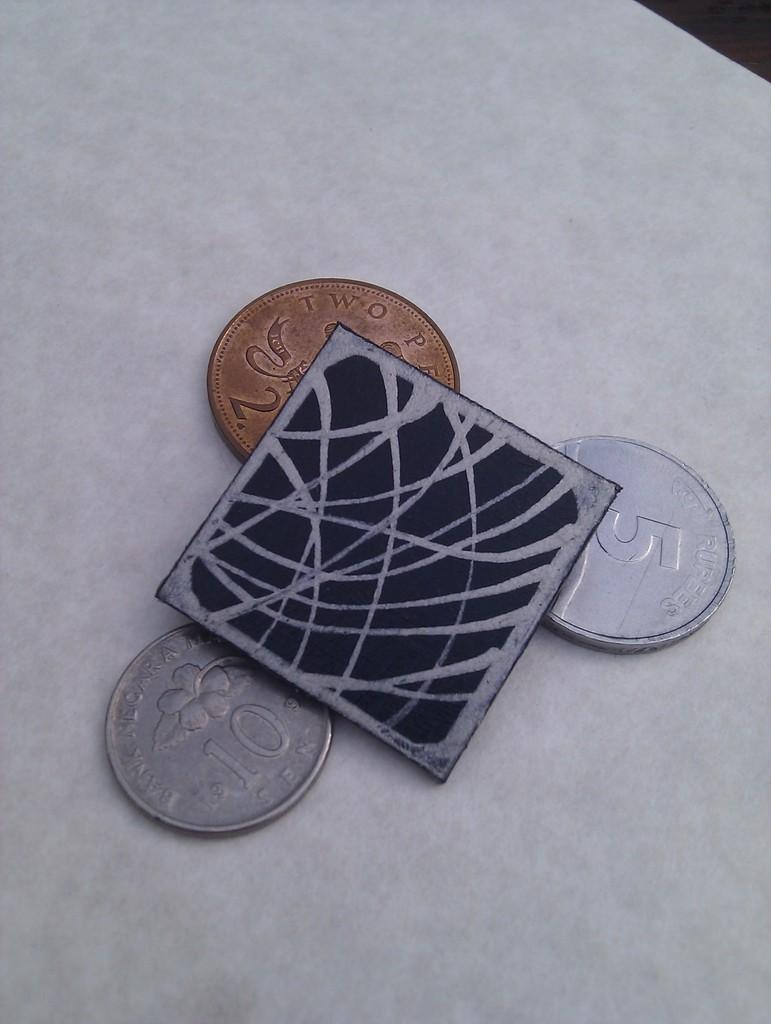<image>
Provide a brief description of the given image. A pile of change with two written on the gold piece. 